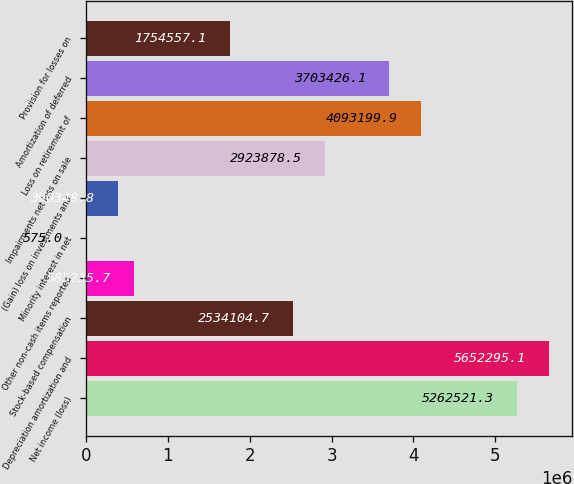Convert chart to OTSL. <chart><loc_0><loc_0><loc_500><loc_500><bar_chart><fcel>Net income (loss)<fcel>Depreciation amortization and<fcel>Stock-based compensation<fcel>Other non-cash items reported<fcel>Minority interest in net<fcel>(Gain) loss on investments and<fcel>Impairments net loss on sale<fcel>Loss on retirement of<fcel>Amortization of deferred<fcel>Provision for losses on<nl><fcel>5.26252e+06<fcel>5.6523e+06<fcel>2.5341e+06<fcel>585236<fcel>575<fcel>390349<fcel>2.92388e+06<fcel>4.0932e+06<fcel>3.70343e+06<fcel>1.75456e+06<nl></chart> 